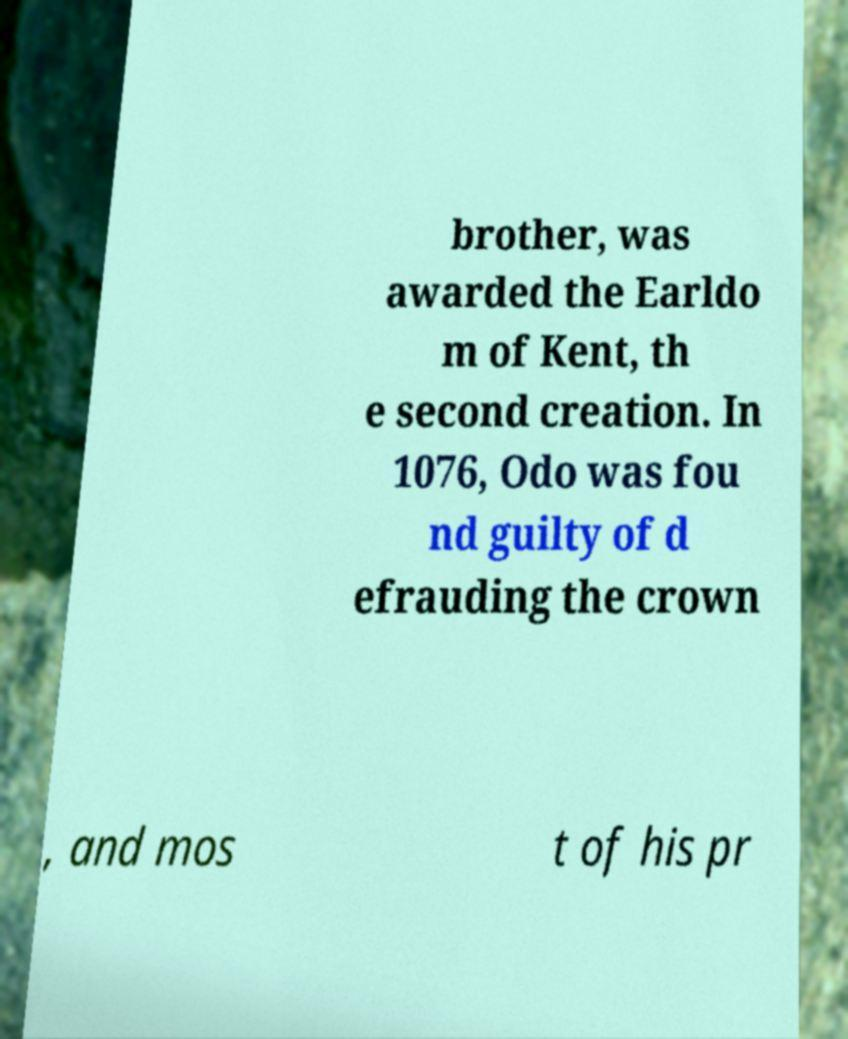What messages or text are displayed in this image? I need them in a readable, typed format. brother, was awarded the Earldo m of Kent, th e second creation. In 1076, Odo was fou nd guilty of d efrauding the crown , and mos t of his pr 